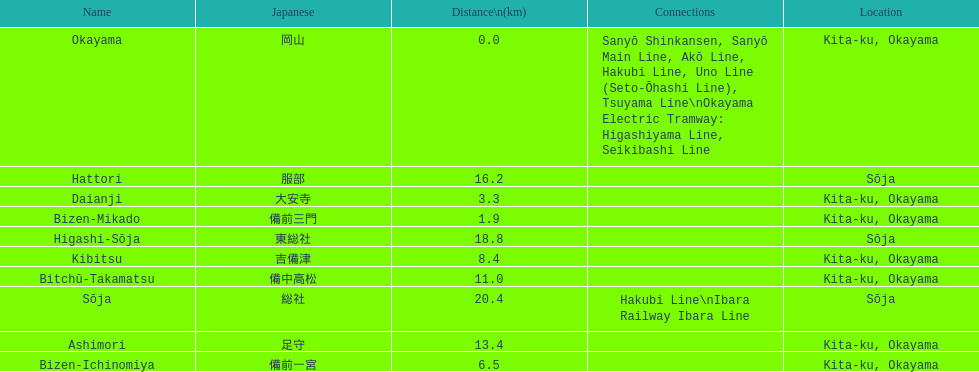How many consecutive stops must you travel through is you board the kibi line at bizen-mikado at depart at kibitsu? 2. 